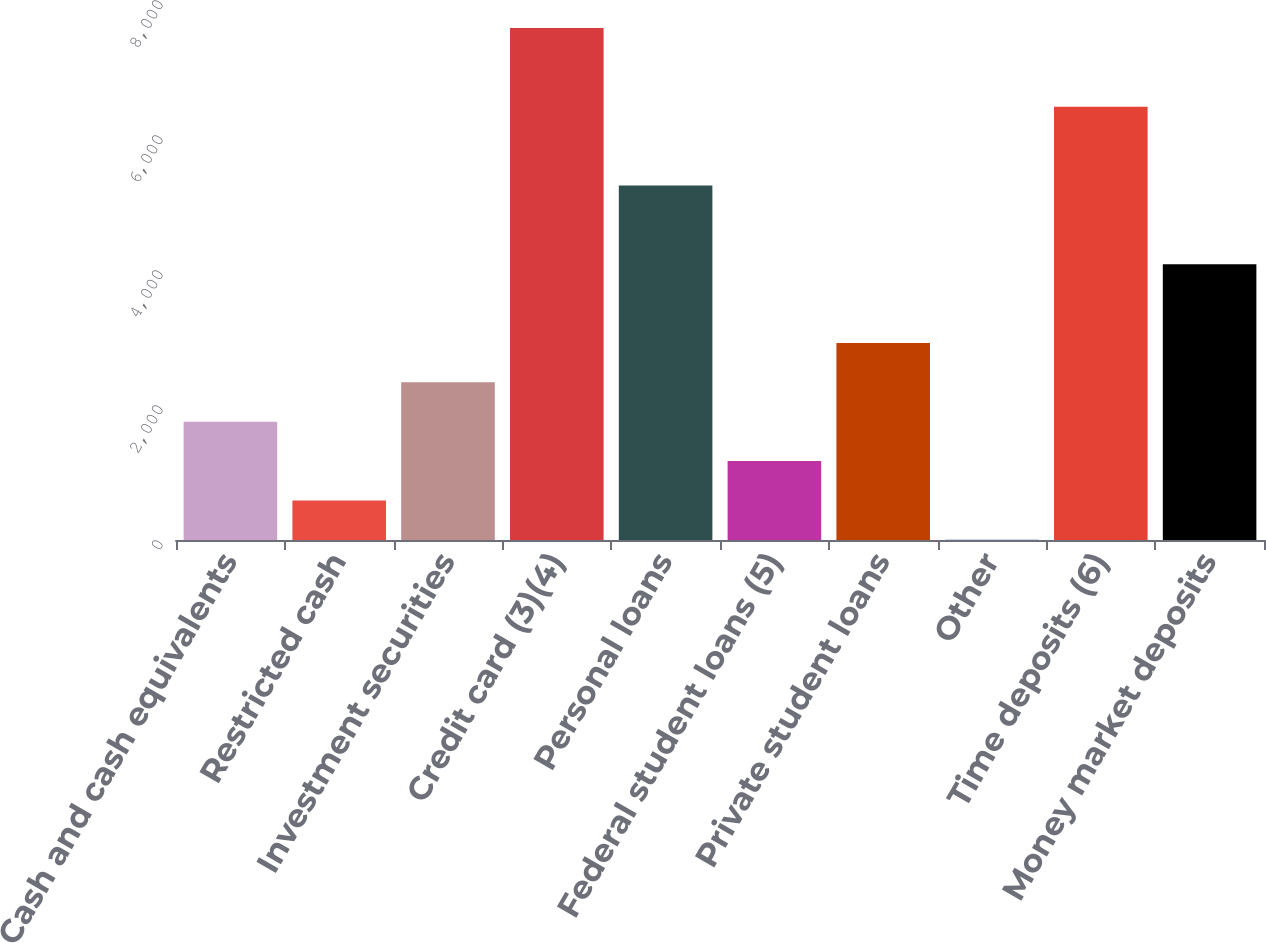Convert chart. <chart><loc_0><loc_0><loc_500><loc_500><bar_chart><fcel>Cash and cash equivalents<fcel>Restricted cash<fcel>Investment securities<fcel>Credit card (3)(4)<fcel>Personal loans<fcel>Federal student loans (5)<fcel>Private student loans<fcel>Other<fcel>Time deposits (6)<fcel>Money market deposits<nl><fcel>1752.2<fcel>585.4<fcel>2335.6<fcel>7586.2<fcel>5252.6<fcel>1168.8<fcel>2919<fcel>2<fcel>6419.4<fcel>4085.8<nl></chart> 